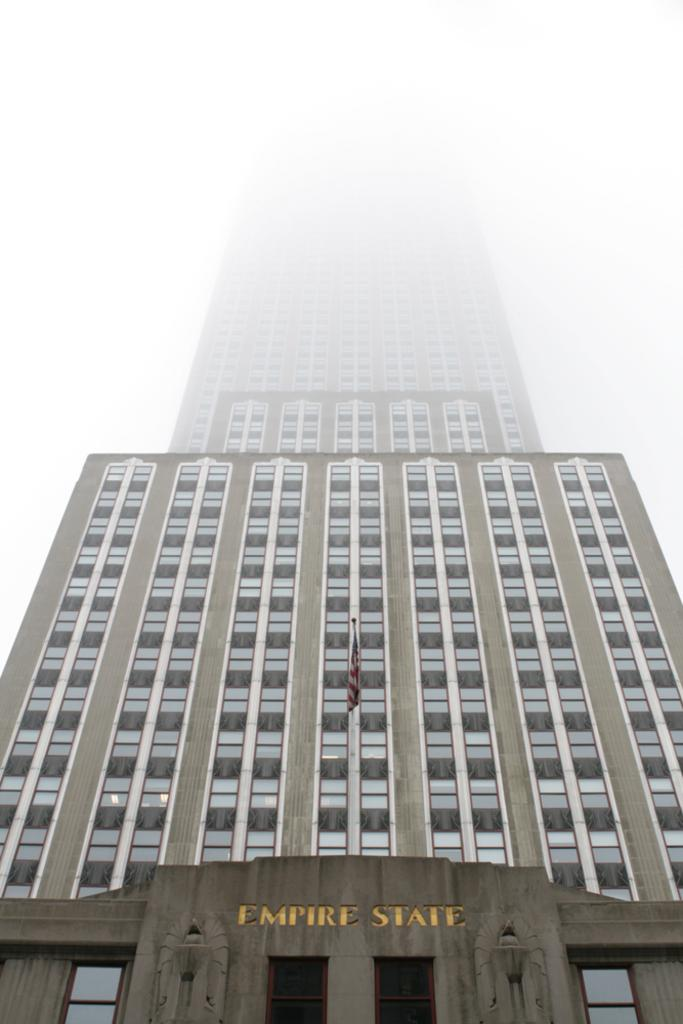What is the main structure in the picture? There is a building in the picture. What distinguishes the building in the image? The building has a flag. What can be read on the flag? There is something written on the flag. What is the color of the background in the image? The background of the image is white in color. Can you see any pigs on the railway in the image? There is no railway or pig present in the image. What type of property is shown in the image? The image only shows a building with a flag and a white background, so it is not possible to determine the type of property. 